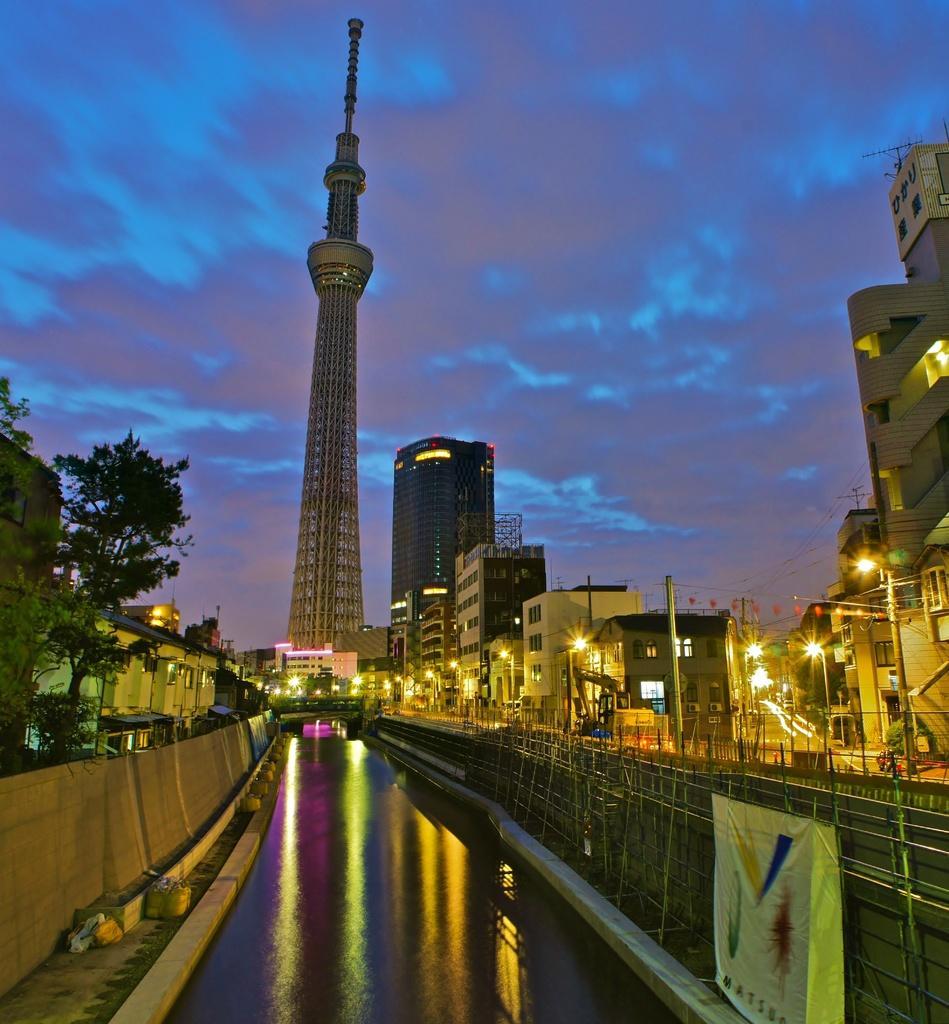How would you summarize this image in a sentence or two? This is a picture of a city. In the center of the picture there are buildings, street lights, poles, roads and a tree. In the foreground there is a canal and wall. Sky is cloudy. 